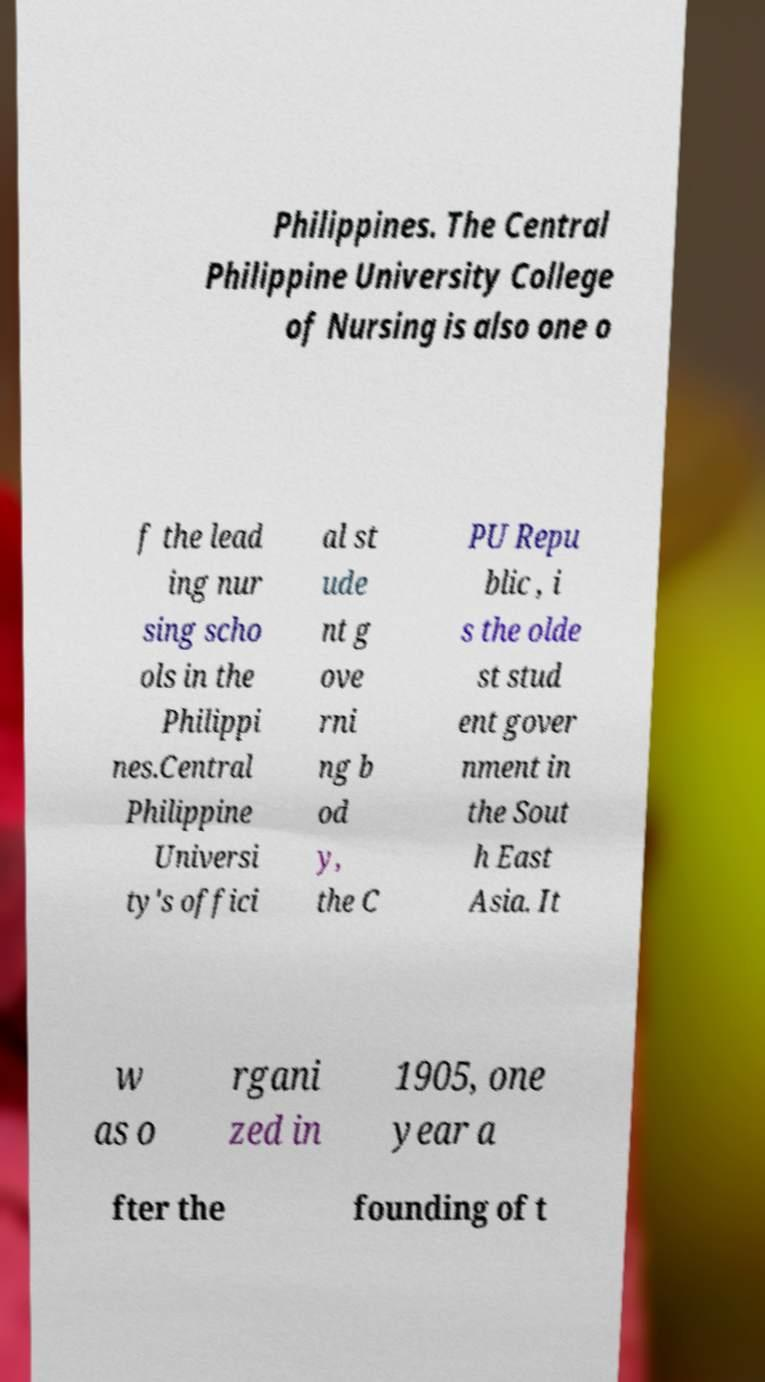What messages or text are displayed in this image? I need them in a readable, typed format. Philippines. The Central Philippine University College of Nursing is also one o f the lead ing nur sing scho ols in the Philippi nes.Central Philippine Universi ty's offici al st ude nt g ove rni ng b od y, the C PU Repu blic , i s the olde st stud ent gover nment in the Sout h East Asia. It w as o rgani zed in 1905, one year a fter the founding of t 